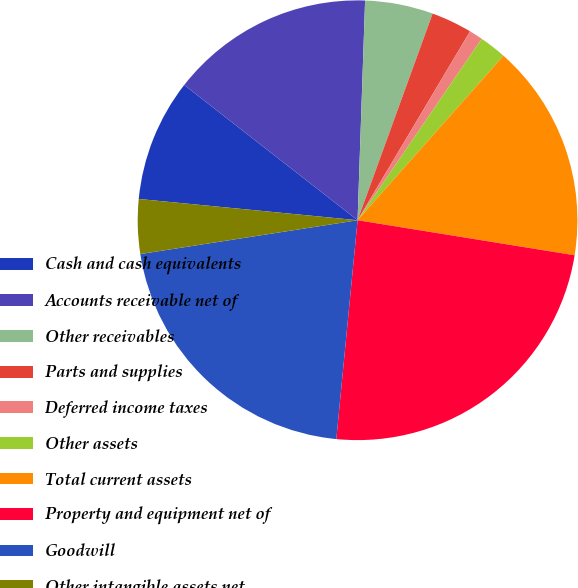Convert chart. <chart><loc_0><loc_0><loc_500><loc_500><pie_chart><fcel>Cash and cash equivalents<fcel>Accounts receivable net of<fcel>Other receivables<fcel>Parts and supplies<fcel>Deferred income taxes<fcel>Other assets<fcel>Total current assets<fcel>Property and equipment net of<fcel>Goodwill<fcel>Other intangible assets net<nl><fcel>9.0%<fcel>15.0%<fcel>5.0%<fcel>3.0%<fcel>1.0%<fcel>2.0%<fcel>16.0%<fcel>23.99%<fcel>21.0%<fcel>4.0%<nl></chart> 